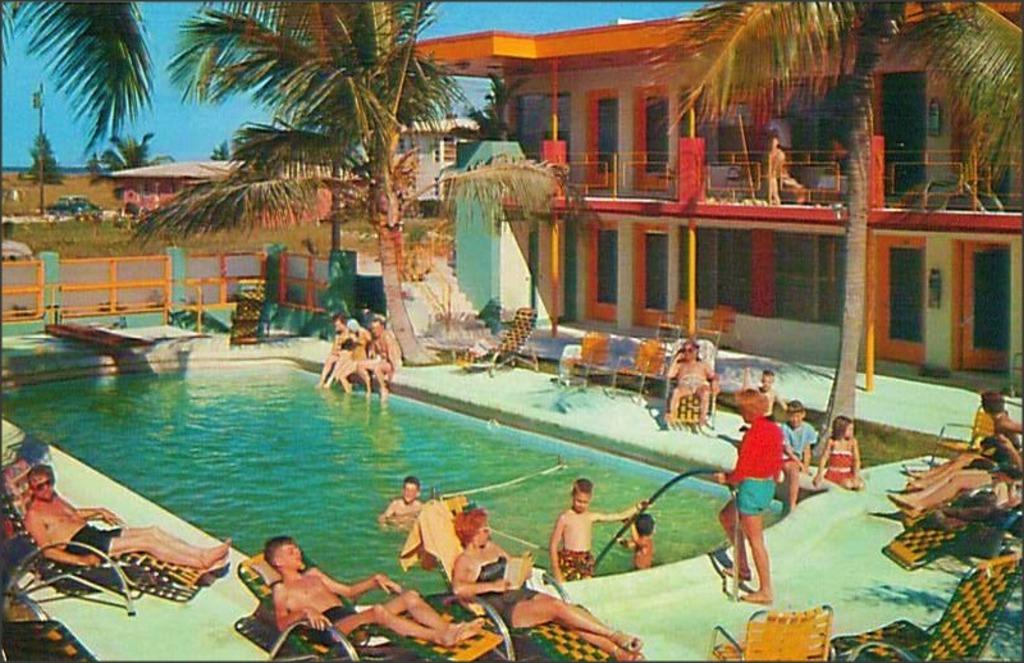What is the main feature in the center of the image? There is a swimming pool in the center of the image. What are the people in the image doing? The people are sitting on chairs. What can be seen in the background of the image? There are buildings, trees, and cars in the background of the image. What type of haircut is the church getting in the image? There is no church present in the image, and therefore no haircut can be observed. 